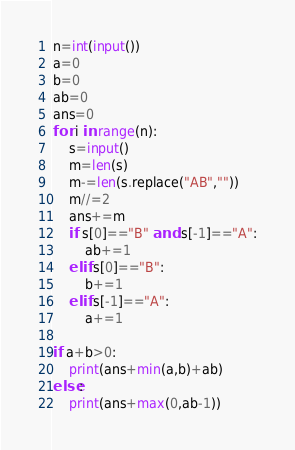<code> <loc_0><loc_0><loc_500><loc_500><_Python_>n=int(input())
a=0
b=0
ab=0
ans=0
for i in range(n):
    s=input()
    m=len(s)
    m-=len(s.replace("AB",""))
    m//=2
    ans+=m
    if s[0]=="B" and s[-1]=="A":
        ab+=1
    elif s[0]=="B":
        b+=1
    elif s[-1]=="A":
        a+=1

if a+b>0:
    print(ans+min(a,b)+ab)
else:
    print(ans+max(0,ab-1))</code> 